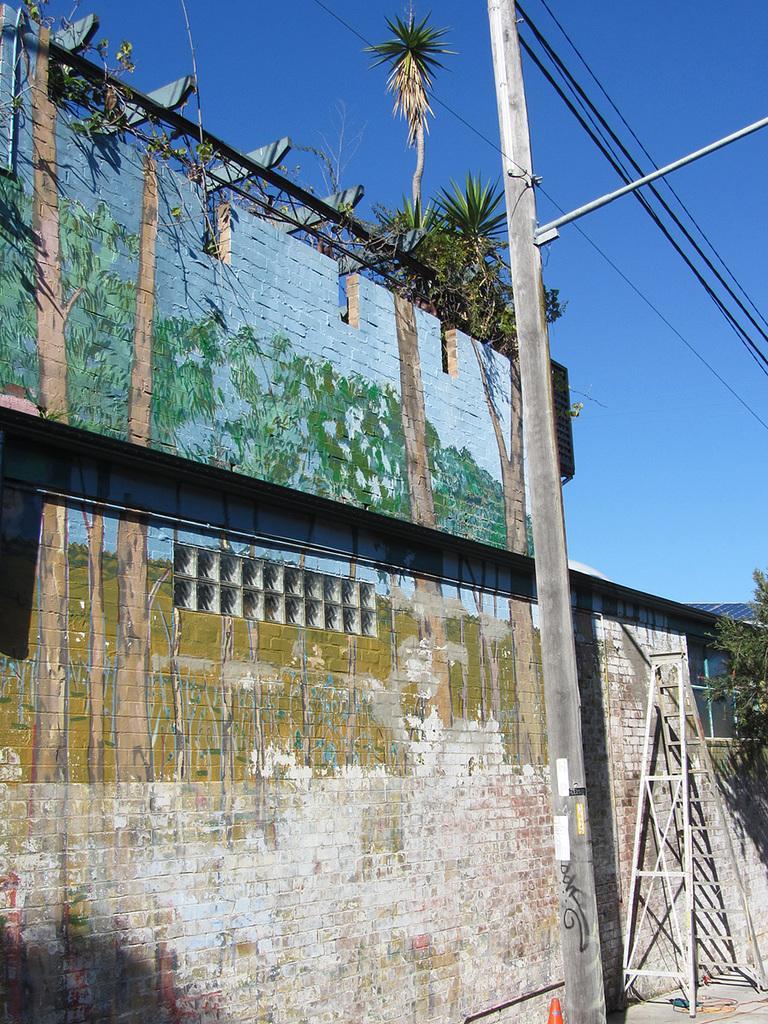Can you describe this image briefly? On the left side, there is a painting on the brick wall of a building. On the right side, there is a pole having cable and there is a ladder on a footpath. In the background, there are trees and there is blue sky. 